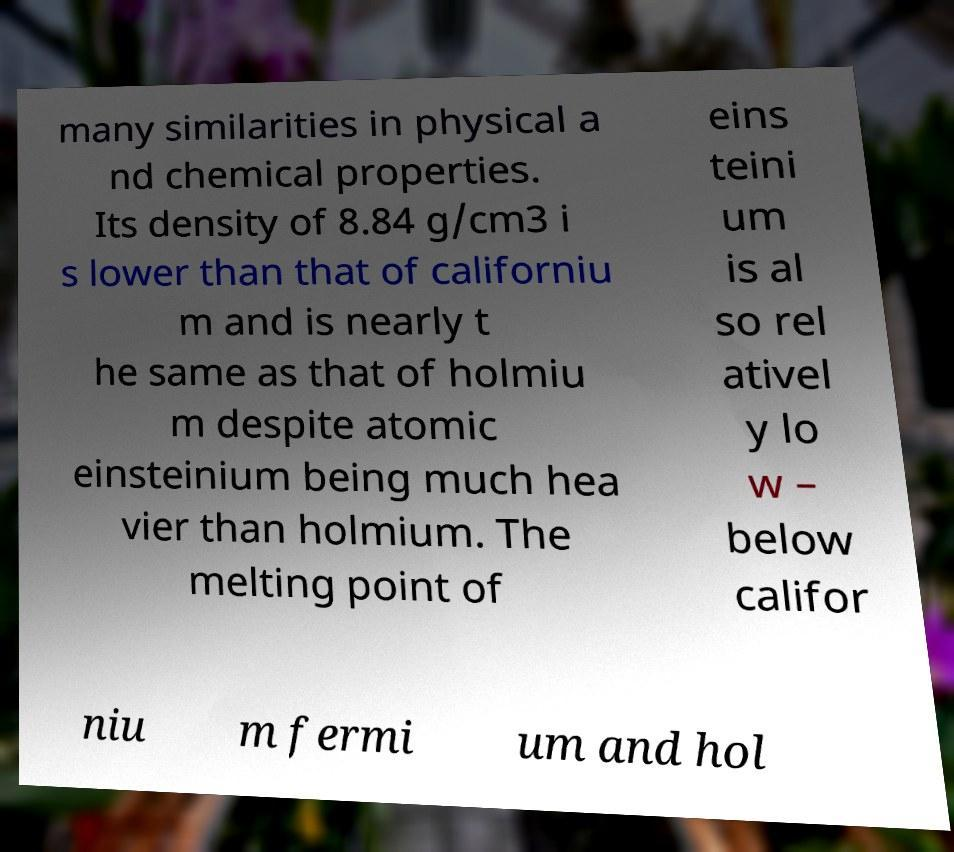Could you assist in decoding the text presented in this image and type it out clearly? many similarities in physical a nd chemical properties. Its density of 8.84 g/cm3 i s lower than that of californiu m and is nearly t he same as that of holmiu m despite atomic einsteinium being much hea vier than holmium. The melting point of eins teini um is al so rel ativel y lo w – below califor niu m fermi um and hol 